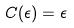Convert formula to latex. <formula><loc_0><loc_0><loc_500><loc_500>C ( \epsilon ) = \epsilon</formula> 